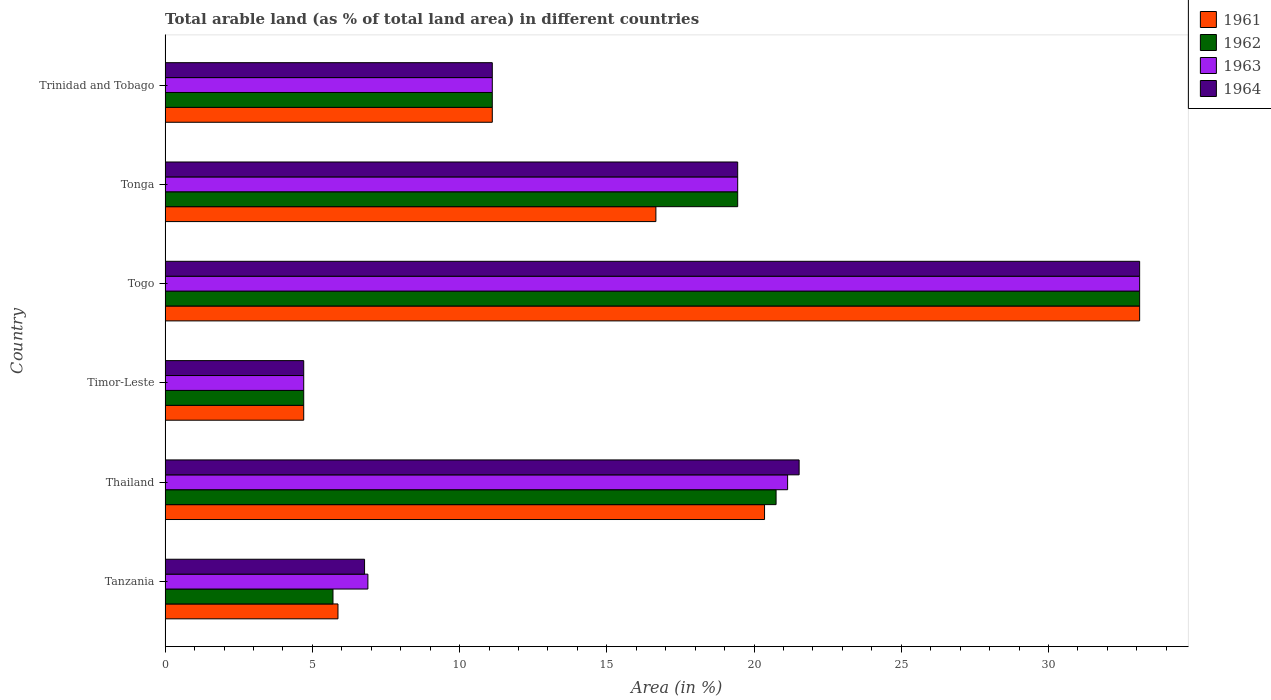How many different coloured bars are there?
Keep it short and to the point. 4. What is the label of the 1st group of bars from the top?
Keep it short and to the point. Trinidad and Tobago. What is the percentage of arable land in 1964 in Thailand?
Provide a succinct answer. 21.53. Across all countries, what is the maximum percentage of arable land in 1962?
Give a very brief answer. 33.09. Across all countries, what is the minimum percentage of arable land in 1961?
Your answer should be very brief. 4.71. In which country was the percentage of arable land in 1963 maximum?
Your response must be concise. Togo. In which country was the percentage of arable land in 1963 minimum?
Offer a terse response. Timor-Leste. What is the total percentage of arable land in 1963 in the graph?
Your answer should be compact. 96.38. What is the difference between the percentage of arable land in 1964 in Thailand and that in Tonga?
Ensure brevity in your answer.  2.09. What is the difference between the percentage of arable land in 1963 in Tanzania and the percentage of arable land in 1962 in Thailand?
Your answer should be compact. -13.86. What is the average percentage of arable land in 1962 per country?
Provide a short and direct response. 15.8. What is the difference between the percentage of arable land in 1962 and percentage of arable land in 1964 in Timor-Leste?
Offer a terse response. 0. What is the ratio of the percentage of arable land in 1961 in Timor-Leste to that in Tonga?
Ensure brevity in your answer.  0.28. Is the percentage of arable land in 1963 in Tanzania less than that in Tonga?
Give a very brief answer. Yes. What is the difference between the highest and the second highest percentage of arable land in 1961?
Give a very brief answer. 12.74. What is the difference between the highest and the lowest percentage of arable land in 1962?
Your answer should be compact. 28.39. In how many countries, is the percentage of arable land in 1964 greater than the average percentage of arable land in 1964 taken over all countries?
Give a very brief answer. 3. Is the sum of the percentage of arable land in 1963 in Tanzania and Thailand greater than the maximum percentage of arable land in 1962 across all countries?
Provide a succinct answer. No. What does the 4th bar from the top in Tanzania represents?
Offer a terse response. 1961. How many bars are there?
Ensure brevity in your answer.  24. What is the difference between two consecutive major ticks on the X-axis?
Your answer should be compact. 5. Are the values on the major ticks of X-axis written in scientific E-notation?
Offer a terse response. No. How are the legend labels stacked?
Make the answer very short. Vertical. What is the title of the graph?
Your answer should be compact. Total arable land (as % of total land area) in different countries. What is the label or title of the X-axis?
Offer a very short reply. Area (in %). What is the label or title of the Y-axis?
Provide a succinct answer. Country. What is the Area (in %) in 1961 in Tanzania?
Offer a very short reply. 5.87. What is the Area (in %) in 1962 in Tanzania?
Give a very brief answer. 5.7. What is the Area (in %) in 1963 in Tanzania?
Provide a succinct answer. 6.89. What is the Area (in %) of 1964 in Tanzania?
Your answer should be compact. 6.77. What is the Area (in %) of 1961 in Thailand?
Provide a short and direct response. 20.36. What is the Area (in %) of 1962 in Thailand?
Your answer should be compact. 20.75. What is the Area (in %) in 1963 in Thailand?
Give a very brief answer. 21.14. What is the Area (in %) in 1964 in Thailand?
Give a very brief answer. 21.53. What is the Area (in %) in 1961 in Timor-Leste?
Your answer should be compact. 4.71. What is the Area (in %) in 1962 in Timor-Leste?
Your answer should be very brief. 4.71. What is the Area (in %) in 1963 in Timor-Leste?
Offer a terse response. 4.71. What is the Area (in %) in 1964 in Timor-Leste?
Give a very brief answer. 4.71. What is the Area (in %) of 1961 in Togo?
Ensure brevity in your answer.  33.09. What is the Area (in %) of 1962 in Togo?
Ensure brevity in your answer.  33.09. What is the Area (in %) in 1963 in Togo?
Offer a terse response. 33.09. What is the Area (in %) of 1964 in Togo?
Your response must be concise. 33.09. What is the Area (in %) in 1961 in Tonga?
Your response must be concise. 16.67. What is the Area (in %) in 1962 in Tonga?
Provide a short and direct response. 19.44. What is the Area (in %) in 1963 in Tonga?
Ensure brevity in your answer.  19.44. What is the Area (in %) of 1964 in Tonga?
Give a very brief answer. 19.44. What is the Area (in %) of 1961 in Trinidad and Tobago?
Offer a terse response. 11.11. What is the Area (in %) in 1962 in Trinidad and Tobago?
Your response must be concise. 11.11. What is the Area (in %) in 1963 in Trinidad and Tobago?
Make the answer very short. 11.11. What is the Area (in %) in 1964 in Trinidad and Tobago?
Make the answer very short. 11.11. Across all countries, what is the maximum Area (in %) of 1961?
Make the answer very short. 33.09. Across all countries, what is the maximum Area (in %) in 1962?
Provide a short and direct response. 33.09. Across all countries, what is the maximum Area (in %) in 1963?
Provide a succinct answer. 33.09. Across all countries, what is the maximum Area (in %) of 1964?
Your response must be concise. 33.09. Across all countries, what is the minimum Area (in %) in 1961?
Make the answer very short. 4.71. Across all countries, what is the minimum Area (in %) of 1962?
Give a very brief answer. 4.71. Across all countries, what is the minimum Area (in %) in 1963?
Provide a succinct answer. 4.71. Across all countries, what is the minimum Area (in %) of 1964?
Your answer should be very brief. 4.71. What is the total Area (in %) of 1961 in the graph?
Provide a succinct answer. 91.81. What is the total Area (in %) of 1962 in the graph?
Offer a terse response. 94.81. What is the total Area (in %) of 1963 in the graph?
Keep it short and to the point. 96.38. What is the total Area (in %) of 1964 in the graph?
Your answer should be compact. 96.66. What is the difference between the Area (in %) of 1961 in Tanzania and that in Thailand?
Your answer should be compact. -14.49. What is the difference between the Area (in %) of 1962 in Tanzania and that in Thailand?
Offer a terse response. -15.05. What is the difference between the Area (in %) in 1963 in Tanzania and that in Thailand?
Keep it short and to the point. -14.25. What is the difference between the Area (in %) of 1964 in Tanzania and that in Thailand?
Give a very brief answer. -14.76. What is the difference between the Area (in %) of 1961 in Tanzania and that in Timor-Leste?
Ensure brevity in your answer.  1.16. What is the difference between the Area (in %) of 1962 in Tanzania and that in Timor-Leste?
Make the answer very short. 0.99. What is the difference between the Area (in %) in 1963 in Tanzania and that in Timor-Leste?
Provide a succinct answer. 2.18. What is the difference between the Area (in %) in 1964 in Tanzania and that in Timor-Leste?
Your answer should be compact. 2.07. What is the difference between the Area (in %) in 1961 in Tanzania and that in Togo?
Your answer should be compact. -27.22. What is the difference between the Area (in %) in 1962 in Tanzania and that in Togo?
Your answer should be very brief. -27.39. What is the difference between the Area (in %) in 1963 in Tanzania and that in Togo?
Your answer should be compact. -26.21. What is the difference between the Area (in %) in 1964 in Tanzania and that in Togo?
Provide a short and direct response. -26.32. What is the difference between the Area (in %) in 1961 in Tanzania and that in Tonga?
Keep it short and to the point. -10.8. What is the difference between the Area (in %) of 1962 in Tanzania and that in Tonga?
Your answer should be very brief. -13.74. What is the difference between the Area (in %) in 1963 in Tanzania and that in Tonga?
Your response must be concise. -12.56. What is the difference between the Area (in %) in 1964 in Tanzania and that in Tonga?
Provide a short and direct response. -12.67. What is the difference between the Area (in %) in 1961 in Tanzania and that in Trinidad and Tobago?
Your response must be concise. -5.24. What is the difference between the Area (in %) of 1962 in Tanzania and that in Trinidad and Tobago?
Provide a short and direct response. -5.41. What is the difference between the Area (in %) of 1963 in Tanzania and that in Trinidad and Tobago?
Ensure brevity in your answer.  -4.22. What is the difference between the Area (in %) in 1964 in Tanzania and that in Trinidad and Tobago?
Provide a succinct answer. -4.34. What is the difference between the Area (in %) of 1961 in Thailand and that in Timor-Leste?
Provide a short and direct response. 15.65. What is the difference between the Area (in %) in 1962 in Thailand and that in Timor-Leste?
Keep it short and to the point. 16.04. What is the difference between the Area (in %) of 1963 in Thailand and that in Timor-Leste?
Offer a very short reply. 16.43. What is the difference between the Area (in %) in 1964 in Thailand and that in Timor-Leste?
Keep it short and to the point. 16.82. What is the difference between the Area (in %) in 1961 in Thailand and that in Togo?
Give a very brief answer. -12.74. What is the difference between the Area (in %) of 1962 in Thailand and that in Togo?
Your answer should be compact. -12.35. What is the difference between the Area (in %) of 1963 in Thailand and that in Togo?
Keep it short and to the point. -11.95. What is the difference between the Area (in %) in 1964 in Thailand and that in Togo?
Keep it short and to the point. -11.56. What is the difference between the Area (in %) in 1961 in Thailand and that in Tonga?
Offer a terse response. 3.69. What is the difference between the Area (in %) of 1962 in Thailand and that in Tonga?
Ensure brevity in your answer.  1.3. What is the difference between the Area (in %) of 1963 in Thailand and that in Tonga?
Keep it short and to the point. 1.7. What is the difference between the Area (in %) of 1964 in Thailand and that in Tonga?
Your answer should be very brief. 2.09. What is the difference between the Area (in %) in 1961 in Thailand and that in Trinidad and Tobago?
Make the answer very short. 9.25. What is the difference between the Area (in %) of 1962 in Thailand and that in Trinidad and Tobago?
Make the answer very short. 9.64. What is the difference between the Area (in %) of 1963 in Thailand and that in Trinidad and Tobago?
Your answer should be compact. 10.03. What is the difference between the Area (in %) of 1964 in Thailand and that in Trinidad and Tobago?
Make the answer very short. 10.42. What is the difference between the Area (in %) of 1961 in Timor-Leste and that in Togo?
Keep it short and to the point. -28.39. What is the difference between the Area (in %) in 1962 in Timor-Leste and that in Togo?
Ensure brevity in your answer.  -28.39. What is the difference between the Area (in %) in 1963 in Timor-Leste and that in Togo?
Ensure brevity in your answer.  -28.39. What is the difference between the Area (in %) in 1964 in Timor-Leste and that in Togo?
Ensure brevity in your answer.  -28.39. What is the difference between the Area (in %) of 1961 in Timor-Leste and that in Tonga?
Make the answer very short. -11.96. What is the difference between the Area (in %) in 1962 in Timor-Leste and that in Tonga?
Provide a short and direct response. -14.74. What is the difference between the Area (in %) of 1963 in Timor-Leste and that in Tonga?
Provide a succinct answer. -14.74. What is the difference between the Area (in %) of 1964 in Timor-Leste and that in Tonga?
Offer a very short reply. -14.74. What is the difference between the Area (in %) of 1961 in Timor-Leste and that in Trinidad and Tobago?
Provide a short and direct response. -6.4. What is the difference between the Area (in %) of 1962 in Timor-Leste and that in Trinidad and Tobago?
Give a very brief answer. -6.4. What is the difference between the Area (in %) of 1963 in Timor-Leste and that in Trinidad and Tobago?
Your answer should be very brief. -6.4. What is the difference between the Area (in %) of 1964 in Timor-Leste and that in Trinidad and Tobago?
Give a very brief answer. -6.4. What is the difference between the Area (in %) in 1961 in Togo and that in Tonga?
Provide a succinct answer. 16.43. What is the difference between the Area (in %) of 1962 in Togo and that in Tonga?
Your answer should be compact. 13.65. What is the difference between the Area (in %) of 1963 in Togo and that in Tonga?
Your response must be concise. 13.65. What is the difference between the Area (in %) of 1964 in Togo and that in Tonga?
Offer a terse response. 13.65. What is the difference between the Area (in %) of 1961 in Togo and that in Trinidad and Tobago?
Keep it short and to the point. 21.98. What is the difference between the Area (in %) in 1962 in Togo and that in Trinidad and Tobago?
Offer a terse response. 21.98. What is the difference between the Area (in %) in 1963 in Togo and that in Trinidad and Tobago?
Your answer should be compact. 21.98. What is the difference between the Area (in %) of 1964 in Togo and that in Trinidad and Tobago?
Offer a very short reply. 21.98. What is the difference between the Area (in %) in 1961 in Tonga and that in Trinidad and Tobago?
Offer a very short reply. 5.56. What is the difference between the Area (in %) in 1962 in Tonga and that in Trinidad and Tobago?
Your answer should be compact. 8.33. What is the difference between the Area (in %) in 1963 in Tonga and that in Trinidad and Tobago?
Your response must be concise. 8.33. What is the difference between the Area (in %) of 1964 in Tonga and that in Trinidad and Tobago?
Your answer should be very brief. 8.33. What is the difference between the Area (in %) in 1961 in Tanzania and the Area (in %) in 1962 in Thailand?
Your response must be concise. -14.88. What is the difference between the Area (in %) of 1961 in Tanzania and the Area (in %) of 1963 in Thailand?
Offer a terse response. -15.27. What is the difference between the Area (in %) in 1961 in Tanzania and the Area (in %) in 1964 in Thailand?
Make the answer very short. -15.66. What is the difference between the Area (in %) in 1962 in Tanzania and the Area (in %) in 1963 in Thailand?
Provide a succinct answer. -15.44. What is the difference between the Area (in %) of 1962 in Tanzania and the Area (in %) of 1964 in Thailand?
Give a very brief answer. -15.83. What is the difference between the Area (in %) in 1963 in Tanzania and the Area (in %) in 1964 in Thailand?
Offer a very short reply. -14.64. What is the difference between the Area (in %) of 1961 in Tanzania and the Area (in %) of 1962 in Timor-Leste?
Provide a short and direct response. 1.16. What is the difference between the Area (in %) in 1961 in Tanzania and the Area (in %) in 1963 in Timor-Leste?
Make the answer very short. 1.16. What is the difference between the Area (in %) in 1961 in Tanzania and the Area (in %) in 1964 in Timor-Leste?
Make the answer very short. 1.16. What is the difference between the Area (in %) of 1963 in Tanzania and the Area (in %) of 1964 in Timor-Leste?
Make the answer very short. 2.18. What is the difference between the Area (in %) in 1961 in Tanzania and the Area (in %) in 1962 in Togo?
Make the answer very short. -27.22. What is the difference between the Area (in %) in 1961 in Tanzania and the Area (in %) in 1963 in Togo?
Provide a short and direct response. -27.22. What is the difference between the Area (in %) in 1961 in Tanzania and the Area (in %) in 1964 in Togo?
Your answer should be compact. -27.22. What is the difference between the Area (in %) of 1962 in Tanzania and the Area (in %) of 1963 in Togo?
Your answer should be very brief. -27.39. What is the difference between the Area (in %) in 1962 in Tanzania and the Area (in %) in 1964 in Togo?
Offer a terse response. -27.39. What is the difference between the Area (in %) in 1963 in Tanzania and the Area (in %) in 1964 in Togo?
Offer a very short reply. -26.21. What is the difference between the Area (in %) in 1961 in Tanzania and the Area (in %) in 1962 in Tonga?
Your answer should be very brief. -13.57. What is the difference between the Area (in %) of 1961 in Tanzania and the Area (in %) of 1963 in Tonga?
Your response must be concise. -13.57. What is the difference between the Area (in %) in 1961 in Tanzania and the Area (in %) in 1964 in Tonga?
Provide a succinct answer. -13.57. What is the difference between the Area (in %) in 1962 in Tanzania and the Area (in %) in 1963 in Tonga?
Ensure brevity in your answer.  -13.74. What is the difference between the Area (in %) of 1962 in Tanzania and the Area (in %) of 1964 in Tonga?
Give a very brief answer. -13.74. What is the difference between the Area (in %) in 1963 in Tanzania and the Area (in %) in 1964 in Tonga?
Give a very brief answer. -12.56. What is the difference between the Area (in %) of 1961 in Tanzania and the Area (in %) of 1962 in Trinidad and Tobago?
Make the answer very short. -5.24. What is the difference between the Area (in %) in 1961 in Tanzania and the Area (in %) in 1963 in Trinidad and Tobago?
Provide a succinct answer. -5.24. What is the difference between the Area (in %) in 1961 in Tanzania and the Area (in %) in 1964 in Trinidad and Tobago?
Keep it short and to the point. -5.24. What is the difference between the Area (in %) in 1962 in Tanzania and the Area (in %) in 1963 in Trinidad and Tobago?
Provide a succinct answer. -5.41. What is the difference between the Area (in %) of 1962 in Tanzania and the Area (in %) of 1964 in Trinidad and Tobago?
Provide a succinct answer. -5.41. What is the difference between the Area (in %) in 1963 in Tanzania and the Area (in %) in 1964 in Trinidad and Tobago?
Give a very brief answer. -4.22. What is the difference between the Area (in %) in 1961 in Thailand and the Area (in %) in 1962 in Timor-Leste?
Offer a terse response. 15.65. What is the difference between the Area (in %) of 1961 in Thailand and the Area (in %) of 1963 in Timor-Leste?
Offer a very short reply. 15.65. What is the difference between the Area (in %) of 1961 in Thailand and the Area (in %) of 1964 in Timor-Leste?
Provide a succinct answer. 15.65. What is the difference between the Area (in %) in 1962 in Thailand and the Area (in %) in 1963 in Timor-Leste?
Your answer should be very brief. 16.04. What is the difference between the Area (in %) of 1962 in Thailand and the Area (in %) of 1964 in Timor-Leste?
Offer a terse response. 16.04. What is the difference between the Area (in %) in 1963 in Thailand and the Area (in %) in 1964 in Timor-Leste?
Offer a terse response. 16.43. What is the difference between the Area (in %) of 1961 in Thailand and the Area (in %) of 1962 in Togo?
Give a very brief answer. -12.74. What is the difference between the Area (in %) in 1961 in Thailand and the Area (in %) in 1963 in Togo?
Make the answer very short. -12.74. What is the difference between the Area (in %) in 1961 in Thailand and the Area (in %) in 1964 in Togo?
Your answer should be compact. -12.74. What is the difference between the Area (in %) of 1962 in Thailand and the Area (in %) of 1963 in Togo?
Give a very brief answer. -12.35. What is the difference between the Area (in %) of 1962 in Thailand and the Area (in %) of 1964 in Togo?
Make the answer very short. -12.35. What is the difference between the Area (in %) of 1963 in Thailand and the Area (in %) of 1964 in Togo?
Provide a short and direct response. -11.95. What is the difference between the Area (in %) in 1961 in Thailand and the Area (in %) in 1962 in Tonga?
Your answer should be compact. 0.91. What is the difference between the Area (in %) of 1961 in Thailand and the Area (in %) of 1963 in Tonga?
Provide a succinct answer. 0.91. What is the difference between the Area (in %) of 1961 in Thailand and the Area (in %) of 1964 in Tonga?
Your answer should be compact. 0.91. What is the difference between the Area (in %) of 1962 in Thailand and the Area (in %) of 1963 in Tonga?
Keep it short and to the point. 1.3. What is the difference between the Area (in %) of 1962 in Thailand and the Area (in %) of 1964 in Tonga?
Your response must be concise. 1.3. What is the difference between the Area (in %) in 1963 in Thailand and the Area (in %) in 1964 in Tonga?
Provide a succinct answer. 1.7. What is the difference between the Area (in %) in 1961 in Thailand and the Area (in %) in 1962 in Trinidad and Tobago?
Your response must be concise. 9.25. What is the difference between the Area (in %) of 1961 in Thailand and the Area (in %) of 1963 in Trinidad and Tobago?
Make the answer very short. 9.25. What is the difference between the Area (in %) of 1961 in Thailand and the Area (in %) of 1964 in Trinidad and Tobago?
Provide a short and direct response. 9.25. What is the difference between the Area (in %) of 1962 in Thailand and the Area (in %) of 1963 in Trinidad and Tobago?
Offer a very short reply. 9.64. What is the difference between the Area (in %) of 1962 in Thailand and the Area (in %) of 1964 in Trinidad and Tobago?
Your answer should be very brief. 9.64. What is the difference between the Area (in %) of 1963 in Thailand and the Area (in %) of 1964 in Trinidad and Tobago?
Give a very brief answer. 10.03. What is the difference between the Area (in %) of 1961 in Timor-Leste and the Area (in %) of 1962 in Togo?
Keep it short and to the point. -28.39. What is the difference between the Area (in %) in 1961 in Timor-Leste and the Area (in %) in 1963 in Togo?
Keep it short and to the point. -28.39. What is the difference between the Area (in %) in 1961 in Timor-Leste and the Area (in %) in 1964 in Togo?
Offer a terse response. -28.39. What is the difference between the Area (in %) in 1962 in Timor-Leste and the Area (in %) in 1963 in Togo?
Give a very brief answer. -28.39. What is the difference between the Area (in %) of 1962 in Timor-Leste and the Area (in %) of 1964 in Togo?
Ensure brevity in your answer.  -28.39. What is the difference between the Area (in %) in 1963 in Timor-Leste and the Area (in %) in 1964 in Togo?
Offer a terse response. -28.39. What is the difference between the Area (in %) of 1961 in Timor-Leste and the Area (in %) of 1962 in Tonga?
Offer a very short reply. -14.74. What is the difference between the Area (in %) in 1961 in Timor-Leste and the Area (in %) in 1963 in Tonga?
Your answer should be very brief. -14.74. What is the difference between the Area (in %) of 1961 in Timor-Leste and the Area (in %) of 1964 in Tonga?
Your answer should be compact. -14.74. What is the difference between the Area (in %) in 1962 in Timor-Leste and the Area (in %) in 1963 in Tonga?
Your answer should be compact. -14.74. What is the difference between the Area (in %) of 1962 in Timor-Leste and the Area (in %) of 1964 in Tonga?
Your answer should be compact. -14.74. What is the difference between the Area (in %) in 1963 in Timor-Leste and the Area (in %) in 1964 in Tonga?
Offer a terse response. -14.74. What is the difference between the Area (in %) in 1961 in Timor-Leste and the Area (in %) in 1962 in Trinidad and Tobago?
Offer a very short reply. -6.4. What is the difference between the Area (in %) of 1961 in Timor-Leste and the Area (in %) of 1963 in Trinidad and Tobago?
Your answer should be very brief. -6.4. What is the difference between the Area (in %) of 1961 in Timor-Leste and the Area (in %) of 1964 in Trinidad and Tobago?
Your answer should be compact. -6.4. What is the difference between the Area (in %) of 1962 in Timor-Leste and the Area (in %) of 1963 in Trinidad and Tobago?
Keep it short and to the point. -6.4. What is the difference between the Area (in %) in 1962 in Timor-Leste and the Area (in %) in 1964 in Trinidad and Tobago?
Keep it short and to the point. -6.4. What is the difference between the Area (in %) of 1963 in Timor-Leste and the Area (in %) of 1964 in Trinidad and Tobago?
Your answer should be compact. -6.4. What is the difference between the Area (in %) in 1961 in Togo and the Area (in %) in 1962 in Tonga?
Keep it short and to the point. 13.65. What is the difference between the Area (in %) of 1961 in Togo and the Area (in %) of 1963 in Tonga?
Your answer should be compact. 13.65. What is the difference between the Area (in %) of 1961 in Togo and the Area (in %) of 1964 in Tonga?
Offer a very short reply. 13.65. What is the difference between the Area (in %) in 1962 in Togo and the Area (in %) in 1963 in Tonga?
Offer a very short reply. 13.65. What is the difference between the Area (in %) of 1962 in Togo and the Area (in %) of 1964 in Tonga?
Give a very brief answer. 13.65. What is the difference between the Area (in %) of 1963 in Togo and the Area (in %) of 1964 in Tonga?
Provide a short and direct response. 13.65. What is the difference between the Area (in %) in 1961 in Togo and the Area (in %) in 1962 in Trinidad and Tobago?
Your answer should be very brief. 21.98. What is the difference between the Area (in %) in 1961 in Togo and the Area (in %) in 1963 in Trinidad and Tobago?
Your response must be concise. 21.98. What is the difference between the Area (in %) of 1961 in Togo and the Area (in %) of 1964 in Trinidad and Tobago?
Give a very brief answer. 21.98. What is the difference between the Area (in %) of 1962 in Togo and the Area (in %) of 1963 in Trinidad and Tobago?
Make the answer very short. 21.98. What is the difference between the Area (in %) of 1962 in Togo and the Area (in %) of 1964 in Trinidad and Tobago?
Offer a terse response. 21.98. What is the difference between the Area (in %) in 1963 in Togo and the Area (in %) in 1964 in Trinidad and Tobago?
Provide a short and direct response. 21.98. What is the difference between the Area (in %) in 1961 in Tonga and the Area (in %) in 1962 in Trinidad and Tobago?
Keep it short and to the point. 5.56. What is the difference between the Area (in %) of 1961 in Tonga and the Area (in %) of 1963 in Trinidad and Tobago?
Make the answer very short. 5.56. What is the difference between the Area (in %) of 1961 in Tonga and the Area (in %) of 1964 in Trinidad and Tobago?
Provide a succinct answer. 5.56. What is the difference between the Area (in %) of 1962 in Tonga and the Area (in %) of 1963 in Trinidad and Tobago?
Provide a succinct answer. 8.33. What is the difference between the Area (in %) of 1962 in Tonga and the Area (in %) of 1964 in Trinidad and Tobago?
Your response must be concise. 8.33. What is the difference between the Area (in %) in 1963 in Tonga and the Area (in %) in 1964 in Trinidad and Tobago?
Offer a very short reply. 8.33. What is the average Area (in %) of 1961 per country?
Provide a succinct answer. 15.3. What is the average Area (in %) of 1962 per country?
Offer a terse response. 15.8. What is the average Area (in %) in 1963 per country?
Make the answer very short. 16.06. What is the average Area (in %) in 1964 per country?
Your answer should be very brief. 16.11. What is the difference between the Area (in %) of 1961 and Area (in %) of 1962 in Tanzania?
Provide a short and direct response. 0.17. What is the difference between the Area (in %) of 1961 and Area (in %) of 1963 in Tanzania?
Provide a short and direct response. -1.02. What is the difference between the Area (in %) of 1961 and Area (in %) of 1964 in Tanzania?
Your answer should be compact. -0.9. What is the difference between the Area (in %) in 1962 and Area (in %) in 1963 in Tanzania?
Offer a terse response. -1.19. What is the difference between the Area (in %) in 1962 and Area (in %) in 1964 in Tanzania?
Your response must be concise. -1.07. What is the difference between the Area (in %) in 1963 and Area (in %) in 1964 in Tanzania?
Offer a very short reply. 0.11. What is the difference between the Area (in %) in 1961 and Area (in %) in 1962 in Thailand?
Provide a succinct answer. -0.39. What is the difference between the Area (in %) of 1961 and Area (in %) of 1963 in Thailand?
Make the answer very short. -0.78. What is the difference between the Area (in %) in 1961 and Area (in %) in 1964 in Thailand?
Offer a terse response. -1.17. What is the difference between the Area (in %) of 1962 and Area (in %) of 1963 in Thailand?
Your answer should be compact. -0.39. What is the difference between the Area (in %) of 1962 and Area (in %) of 1964 in Thailand?
Provide a short and direct response. -0.78. What is the difference between the Area (in %) in 1963 and Area (in %) in 1964 in Thailand?
Ensure brevity in your answer.  -0.39. What is the difference between the Area (in %) in 1962 and Area (in %) in 1963 in Timor-Leste?
Your answer should be very brief. 0. What is the difference between the Area (in %) of 1962 and Area (in %) of 1964 in Timor-Leste?
Your answer should be very brief. 0. What is the difference between the Area (in %) of 1961 and Area (in %) of 1962 in Togo?
Keep it short and to the point. 0. What is the difference between the Area (in %) in 1961 and Area (in %) in 1963 in Togo?
Your answer should be compact. 0. What is the difference between the Area (in %) in 1962 and Area (in %) in 1963 in Togo?
Ensure brevity in your answer.  0. What is the difference between the Area (in %) of 1963 and Area (in %) of 1964 in Togo?
Provide a short and direct response. 0. What is the difference between the Area (in %) in 1961 and Area (in %) in 1962 in Tonga?
Ensure brevity in your answer.  -2.78. What is the difference between the Area (in %) in 1961 and Area (in %) in 1963 in Tonga?
Your answer should be compact. -2.78. What is the difference between the Area (in %) in 1961 and Area (in %) in 1964 in Tonga?
Make the answer very short. -2.78. What is the difference between the Area (in %) in 1962 and Area (in %) in 1963 in Tonga?
Your answer should be compact. 0. What is the difference between the Area (in %) in 1962 and Area (in %) in 1964 in Tonga?
Make the answer very short. 0. What is the difference between the Area (in %) of 1963 and Area (in %) of 1964 in Tonga?
Give a very brief answer. 0. What is the ratio of the Area (in %) of 1961 in Tanzania to that in Thailand?
Make the answer very short. 0.29. What is the ratio of the Area (in %) of 1962 in Tanzania to that in Thailand?
Provide a short and direct response. 0.27. What is the ratio of the Area (in %) in 1963 in Tanzania to that in Thailand?
Provide a short and direct response. 0.33. What is the ratio of the Area (in %) of 1964 in Tanzania to that in Thailand?
Offer a terse response. 0.31. What is the ratio of the Area (in %) in 1961 in Tanzania to that in Timor-Leste?
Provide a succinct answer. 1.25. What is the ratio of the Area (in %) of 1962 in Tanzania to that in Timor-Leste?
Provide a short and direct response. 1.21. What is the ratio of the Area (in %) of 1963 in Tanzania to that in Timor-Leste?
Your answer should be very brief. 1.46. What is the ratio of the Area (in %) of 1964 in Tanzania to that in Timor-Leste?
Provide a succinct answer. 1.44. What is the ratio of the Area (in %) in 1961 in Tanzania to that in Togo?
Offer a very short reply. 0.18. What is the ratio of the Area (in %) of 1962 in Tanzania to that in Togo?
Make the answer very short. 0.17. What is the ratio of the Area (in %) of 1963 in Tanzania to that in Togo?
Offer a terse response. 0.21. What is the ratio of the Area (in %) of 1964 in Tanzania to that in Togo?
Make the answer very short. 0.2. What is the ratio of the Area (in %) of 1961 in Tanzania to that in Tonga?
Keep it short and to the point. 0.35. What is the ratio of the Area (in %) of 1962 in Tanzania to that in Tonga?
Offer a terse response. 0.29. What is the ratio of the Area (in %) of 1963 in Tanzania to that in Tonga?
Keep it short and to the point. 0.35. What is the ratio of the Area (in %) of 1964 in Tanzania to that in Tonga?
Ensure brevity in your answer.  0.35. What is the ratio of the Area (in %) of 1961 in Tanzania to that in Trinidad and Tobago?
Make the answer very short. 0.53. What is the ratio of the Area (in %) in 1962 in Tanzania to that in Trinidad and Tobago?
Keep it short and to the point. 0.51. What is the ratio of the Area (in %) in 1963 in Tanzania to that in Trinidad and Tobago?
Provide a succinct answer. 0.62. What is the ratio of the Area (in %) of 1964 in Tanzania to that in Trinidad and Tobago?
Ensure brevity in your answer.  0.61. What is the ratio of the Area (in %) of 1961 in Thailand to that in Timor-Leste?
Your answer should be compact. 4.32. What is the ratio of the Area (in %) in 1962 in Thailand to that in Timor-Leste?
Your answer should be very brief. 4.41. What is the ratio of the Area (in %) of 1963 in Thailand to that in Timor-Leste?
Make the answer very short. 4.49. What is the ratio of the Area (in %) of 1964 in Thailand to that in Timor-Leste?
Make the answer very short. 4.57. What is the ratio of the Area (in %) of 1961 in Thailand to that in Togo?
Ensure brevity in your answer.  0.62. What is the ratio of the Area (in %) in 1962 in Thailand to that in Togo?
Provide a short and direct response. 0.63. What is the ratio of the Area (in %) of 1963 in Thailand to that in Togo?
Ensure brevity in your answer.  0.64. What is the ratio of the Area (in %) of 1964 in Thailand to that in Togo?
Make the answer very short. 0.65. What is the ratio of the Area (in %) in 1961 in Thailand to that in Tonga?
Your answer should be very brief. 1.22. What is the ratio of the Area (in %) in 1962 in Thailand to that in Tonga?
Offer a terse response. 1.07. What is the ratio of the Area (in %) of 1963 in Thailand to that in Tonga?
Offer a very short reply. 1.09. What is the ratio of the Area (in %) in 1964 in Thailand to that in Tonga?
Ensure brevity in your answer.  1.11. What is the ratio of the Area (in %) in 1961 in Thailand to that in Trinidad and Tobago?
Offer a terse response. 1.83. What is the ratio of the Area (in %) in 1962 in Thailand to that in Trinidad and Tobago?
Keep it short and to the point. 1.87. What is the ratio of the Area (in %) in 1963 in Thailand to that in Trinidad and Tobago?
Offer a terse response. 1.9. What is the ratio of the Area (in %) of 1964 in Thailand to that in Trinidad and Tobago?
Provide a succinct answer. 1.94. What is the ratio of the Area (in %) in 1961 in Timor-Leste to that in Togo?
Make the answer very short. 0.14. What is the ratio of the Area (in %) in 1962 in Timor-Leste to that in Togo?
Your answer should be compact. 0.14. What is the ratio of the Area (in %) in 1963 in Timor-Leste to that in Togo?
Keep it short and to the point. 0.14. What is the ratio of the Area (in %) in 1964 in Timor-Leste to that in Togo?
Your response must be concise. 0.14. What is the ratio of the Area (in %) of 1961 in Timor-Leste to that in Tonga?
Give a very brief answer. 0.28. What is the ratio of the Area (in %) of 1962 in Timor-Leste to that in Tonga?
Give a very brief answer. 0.24. What is the ratio of the Area (in %) of 1963 in Timor-Leste to that in Tonga?
Give a very brief answer. 0.24. What is the ratio of the Area (in %) of 1964 in Timor-Leste to that in Tonga?
Make the answer very short. 0.24. What is the ratio of the Area (in %) of 1961 in Timor-Leste to that in Trinidad and Tobago?
Keep it short and to the point. 0.42. What is the ratio of the Area (in %) of 1962 in Timor-Leste to that in Trinidad and Tobago?
Offer a very short reply. 0.42. What is the ratio of the Area (in %) of 1963 in Timor-Leste to that in Trinidad and Tobago?
Your answer should be compact. 0.42. What is the ratio of the Area (in %) of 1964 in Timor-Leste to that in Trinidad and Tobago?
Offer a very short reply. 0.42. What is the ratio of the Area (in %) in 1961 in Togo to that in Tonga?
Offer a very short reply. 1.99. What is the ratio of the Area (in %) of 1962 in Togo to that in Tonga?
Your response must be concise. 1.7. What is the ratio of the Area (in %) in 1963 in Togo to that in Tonga?
Make the answer very short. 1.7. What is the ratio of the Area (in %) in 1964 in Togo to that in Tonga?
Keep it short and to the point. 1.7. What is the ratio of the Area (in %) in 1961 in Togo to that in Trinidad and Tobago?
Offer a very short reply. 2.98. What is the ratio of the Area (in %) of 1962 in Togo to that in Trinidad and Tobago?
Provide a succinct answer. 2.98. What is the ratio of the Area (in %) in 1963 in Togo to that in Trinidad and Tobago?
Your response must be concise. 2.98. What is the ratio of the Area (in %) of 1964 in Togo to that in Trinidad and Tobago?
Provide a short and direct response. 2.98. What is the ratio of the Area (in %) of 1961 in Tonga to that in Trinidad and Tobago?
Your answer should be very brief. 1.5. What is the ratio of the Area (in %) of 1962 in Tonga to that in Trinidad and Tobago?
Keep it short and to the point. 1.75. What is the ratio of the Area (in %) of 1964 in Tonga to that in Trinidad and Tobago?
Your answer should be compact. 1.75. What is the difference between the highest and the second highest Area (in %) of 1961?
Ensure brevity in your answer.  12.74. What is the difference between the highest and the second highest Area (in %) in 1962?
Your answer should be very brief. 12.35. What is the difference between the highest and the second highest Area (in %) in 1963?
Your response must be concise. 11.95. What is the difference between the highest and the second highest Area (in %) of 1964?
Offer a very short reply. 11.56. What is the difference between the highest and the lowest Area (in %) in 1961?
Your answer should be compact. 28.39. What is the difference between the highest and the lowest Area (in %) of 1962?
Make the answer very short. 28.39. What is the difference between the highest and the lowest Area (in %) of 1963?
Your answer should be compact. 28.39. What is the difference between the highest and the lowest Area (in %) in 1964?
Give a very brief answer. 28.39. 